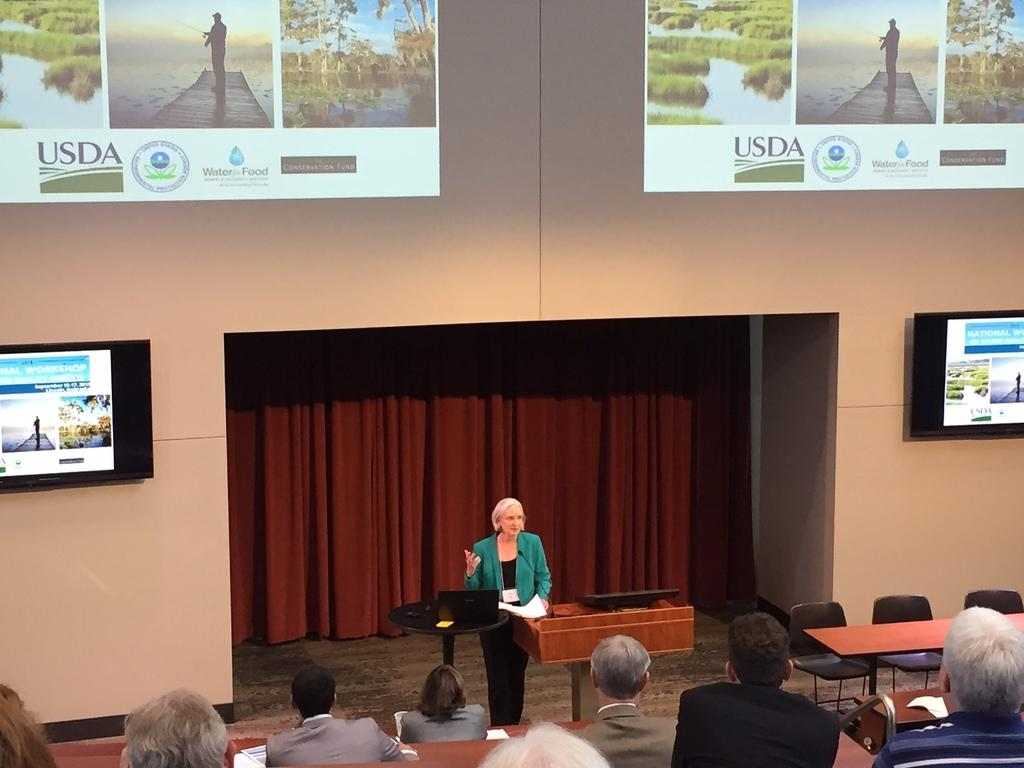What are the people in the image doing? The persons sitting in the image are likely engaged in some activity or conversation. Can you describe the man in the image? There is a man standing in the image. What type of furniture is present in the image? There is a chair and a bench in the image. What is the background of the image like? There is a wall, a screen, and a curtain in the image. What type of calculator can be seen on the wall in the image? There is no calculator present on the wall in the image. Can you tell me how many matches are on the bench in the image? There are no matches visible on the bench in the image. 